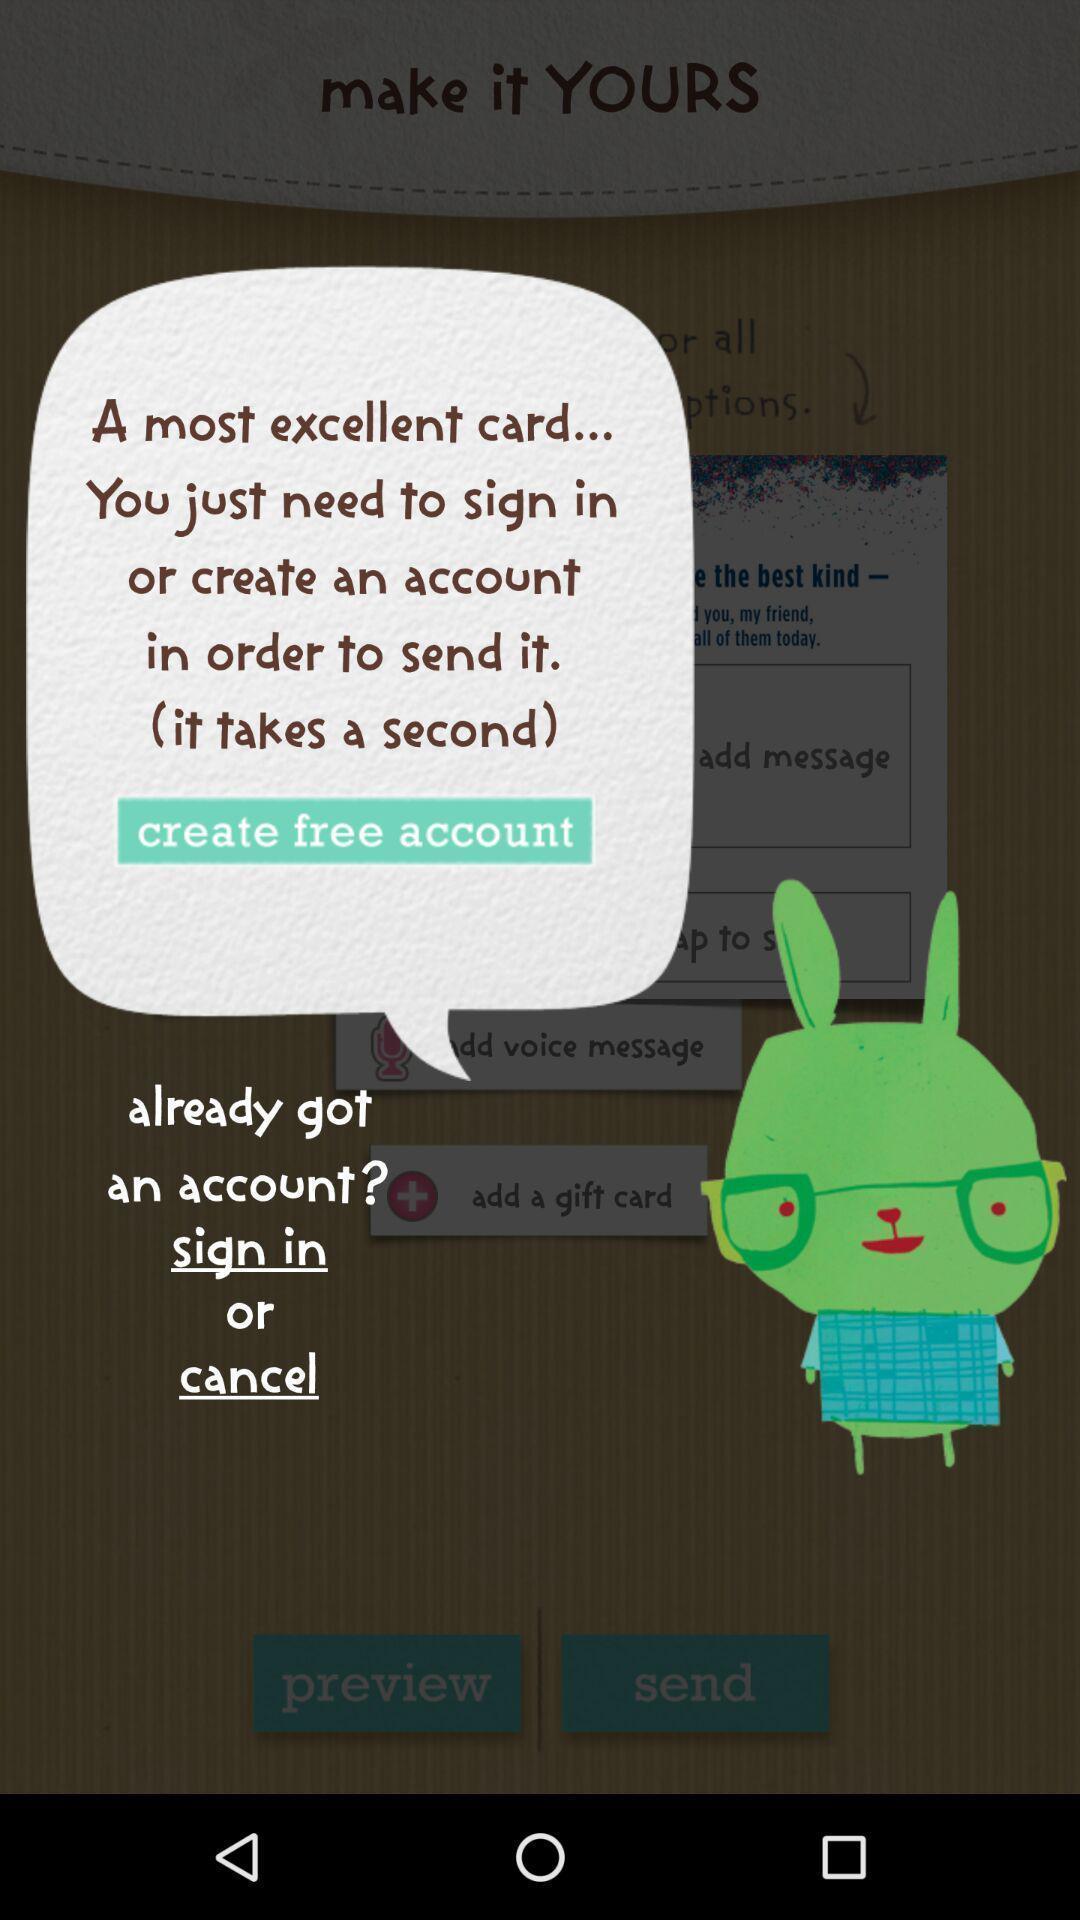Describe the key features of this screenshot. Sign in page. 